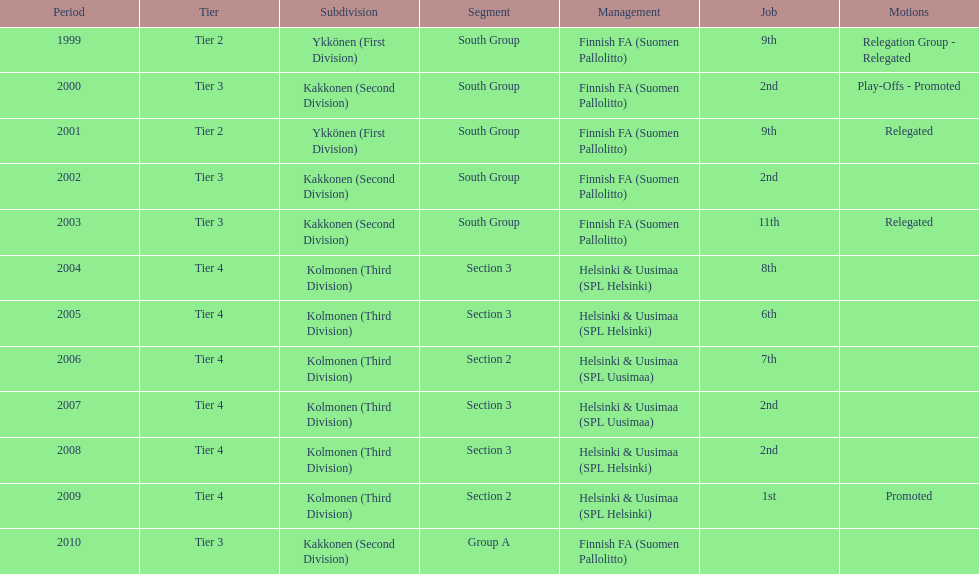Of the third division, how many were in section3? 4. 